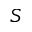Convert formula to latex. <formula><loc_0><loc_0><loc_500><loc_500>S</formula> 